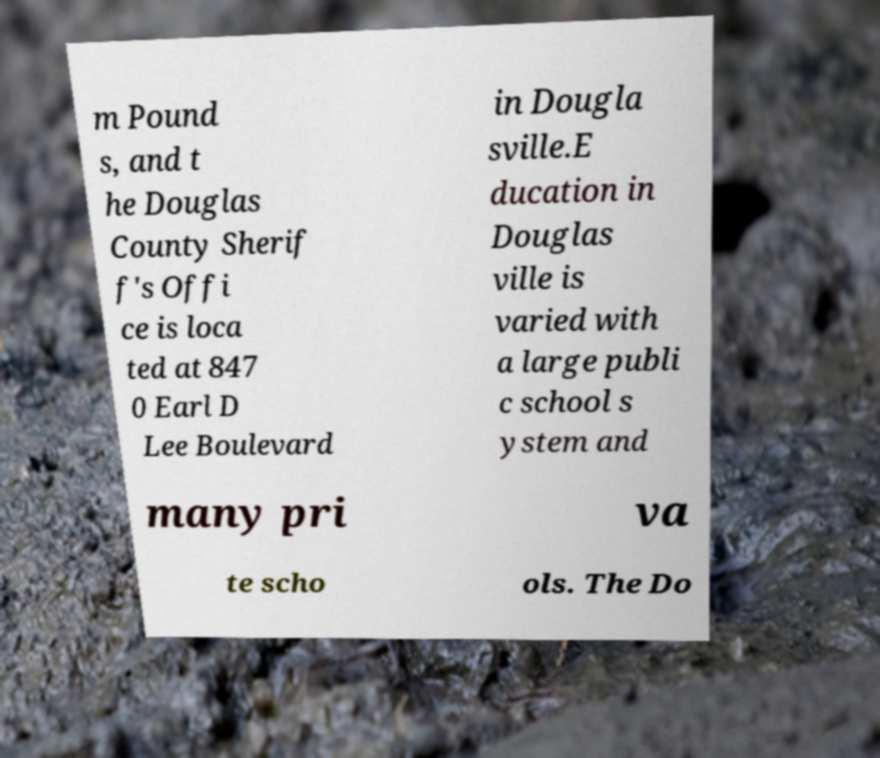Please read and relay the text visible in this image. What does it say? m Pound s, and t he Douglas County Sherif f's Offi ce is loca ted at 847 0 Earl D Lee Boulevard in Dougla sville.E ducation in Douglas ville is varied with a large publi c school s ystem and many pri va te scho ols. The Do 